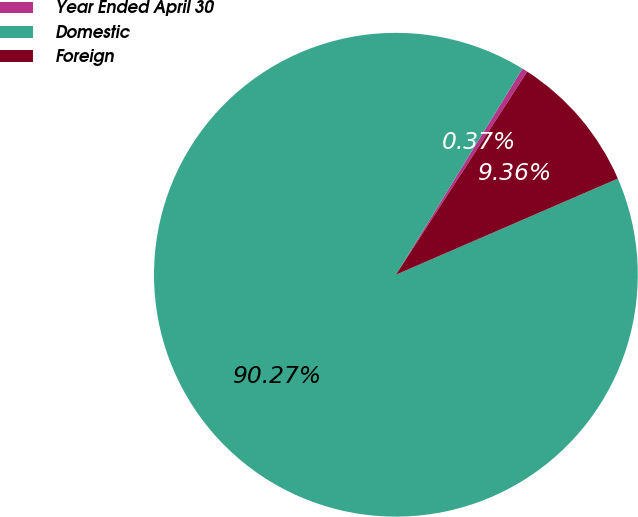<chart> <loc_0><loc_0><loc_500><loc_500><pie_chart><fcel>Year Ended April 30<fcel>Domestic<fcel>Foreign<nl><fcel>0.37%<fcel>90.27%<fcel>9.36%<nl></chart> 